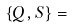<formula> <loc_0><loc_0><loc_500><loc_500>\left \{ Q , S \right \} =</formula> 